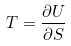Convert formula to latex. <formula><loc_0><loc_0><loc_500><loc_500>T = \frac { \partial U } { \partial S }</formula> 